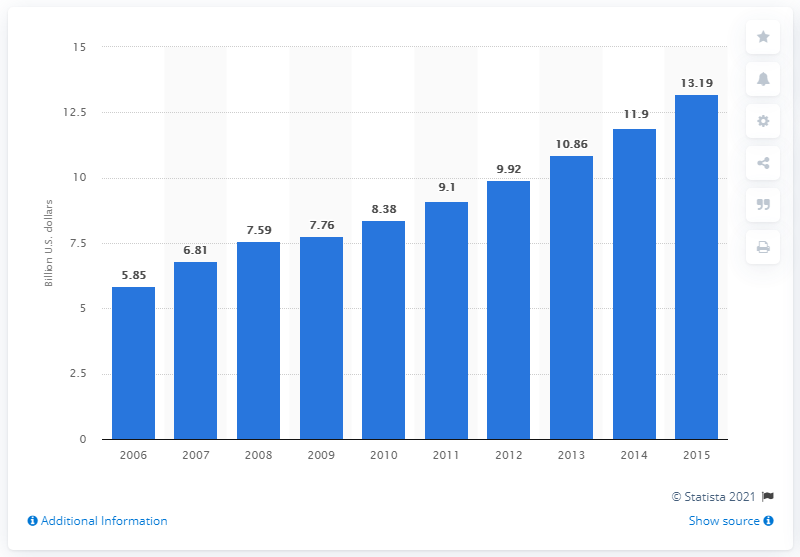Indicate a few pertinent items in this graphic. The global sales of food intolerance products in 2010 were 8.38 billion. By 2015, it is projected that the sales of food intolerance products will be approximately 13.19. 